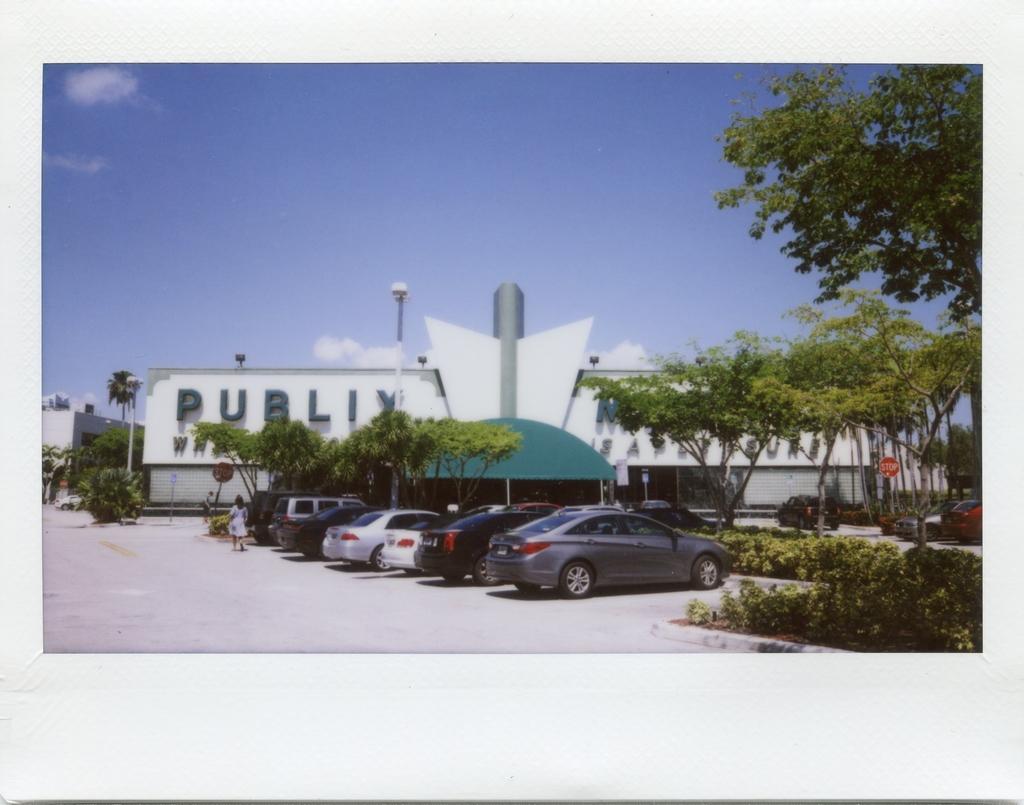How would you summarize this image in a sentence or two? In this image we can see a photograph. In this photograph there are buildings and trees and we can see cars. On the left there is a lady. We can see a pole. In the background there is sky. There are bushes. 